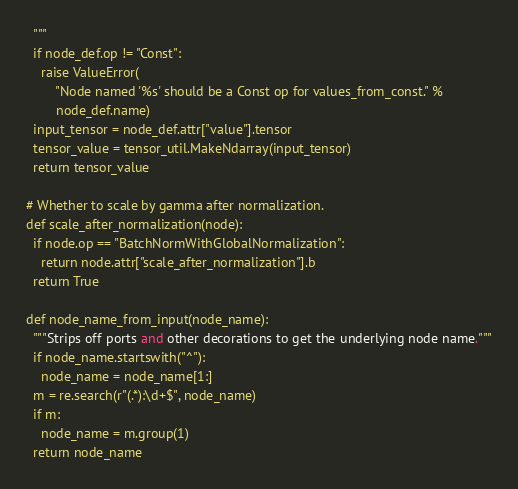<code> <loc_0><loc_0><loc_500><loc_500><_Python_>  """
  if node_def.op != "Const":
    raise ValueError(
        "Node named '%s' should be a Const op for values_from_const." %
        node_def.name)
  input_tensor = node_def.attr["value"].tensor
  tensor_value = tensor_util.MakeNdarray(input_tensor)
  return tensor_value

# Whether to scale by gamma after normalization.
def scale_after_normalization(node):
  if node.op == "BatchNormWithGlobalNormalization":
    return node.attr["scale_after_normalization"].b
  return True

def node_name_from_input(node_name):
  """Strips off ports and other decorations to get the underlying node name."""
  if node_name.startswith("^"):
    node_name = node_name[1:]
  m = re.search(r"(.*):\d+$", node_name)
  if m:
    node_name = m.group(1)
  return node_name
</code> 